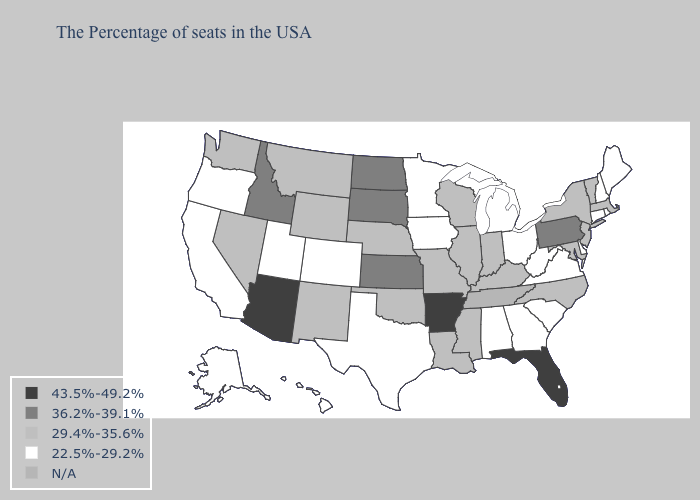Name the states that have a value in the range 43.5%-49.2%?
Keep it brief. Florida, Arkansas, Arizona. What is the value of South Dakota?
Quick response, please. 36.2%-39.1%. What is the highest value in states that border New Jersey?
Answer briefly. 36.2%-39.1%. How many symbols are there in the legend?
Quick response, please. 5. Name the states that have a value in the range 29.4%-35.6%?
Concise answer only. Massachusetts, Vermont, New York, New Jersey, Maryland, North Carolina, Kentucky, Indiana, Wisconsin, Illinois, Mississippi, Louisiana, Missouri, Nebraska, Oklahoma, Wyoming, New Mexico, Montana, Nevada, Washington. How many symbols are there in the legend?
Quick response, please. 5. Name the states that have a value in the range 43.5%-49.2%?
Keep it brief. Florida, Arkansas, Arizona. Does Michigan have the lowest value in the MidWest?
Answer briefly. Yes. What is the value of Washington?
Keep it brief. 29.4%-35.6%. Does Louisiana have the highest value in the USA?
Concise answer only. No. Is the legend a continuous bar?
Quick response, please. No. What is the value of Maryland?
Concise answer only. 29.4%-35.6%. Does the map have missing data?
Keep it brief. Yes. Does Hawaii have the lowest value in the West?
Answer briefly. Yes. 